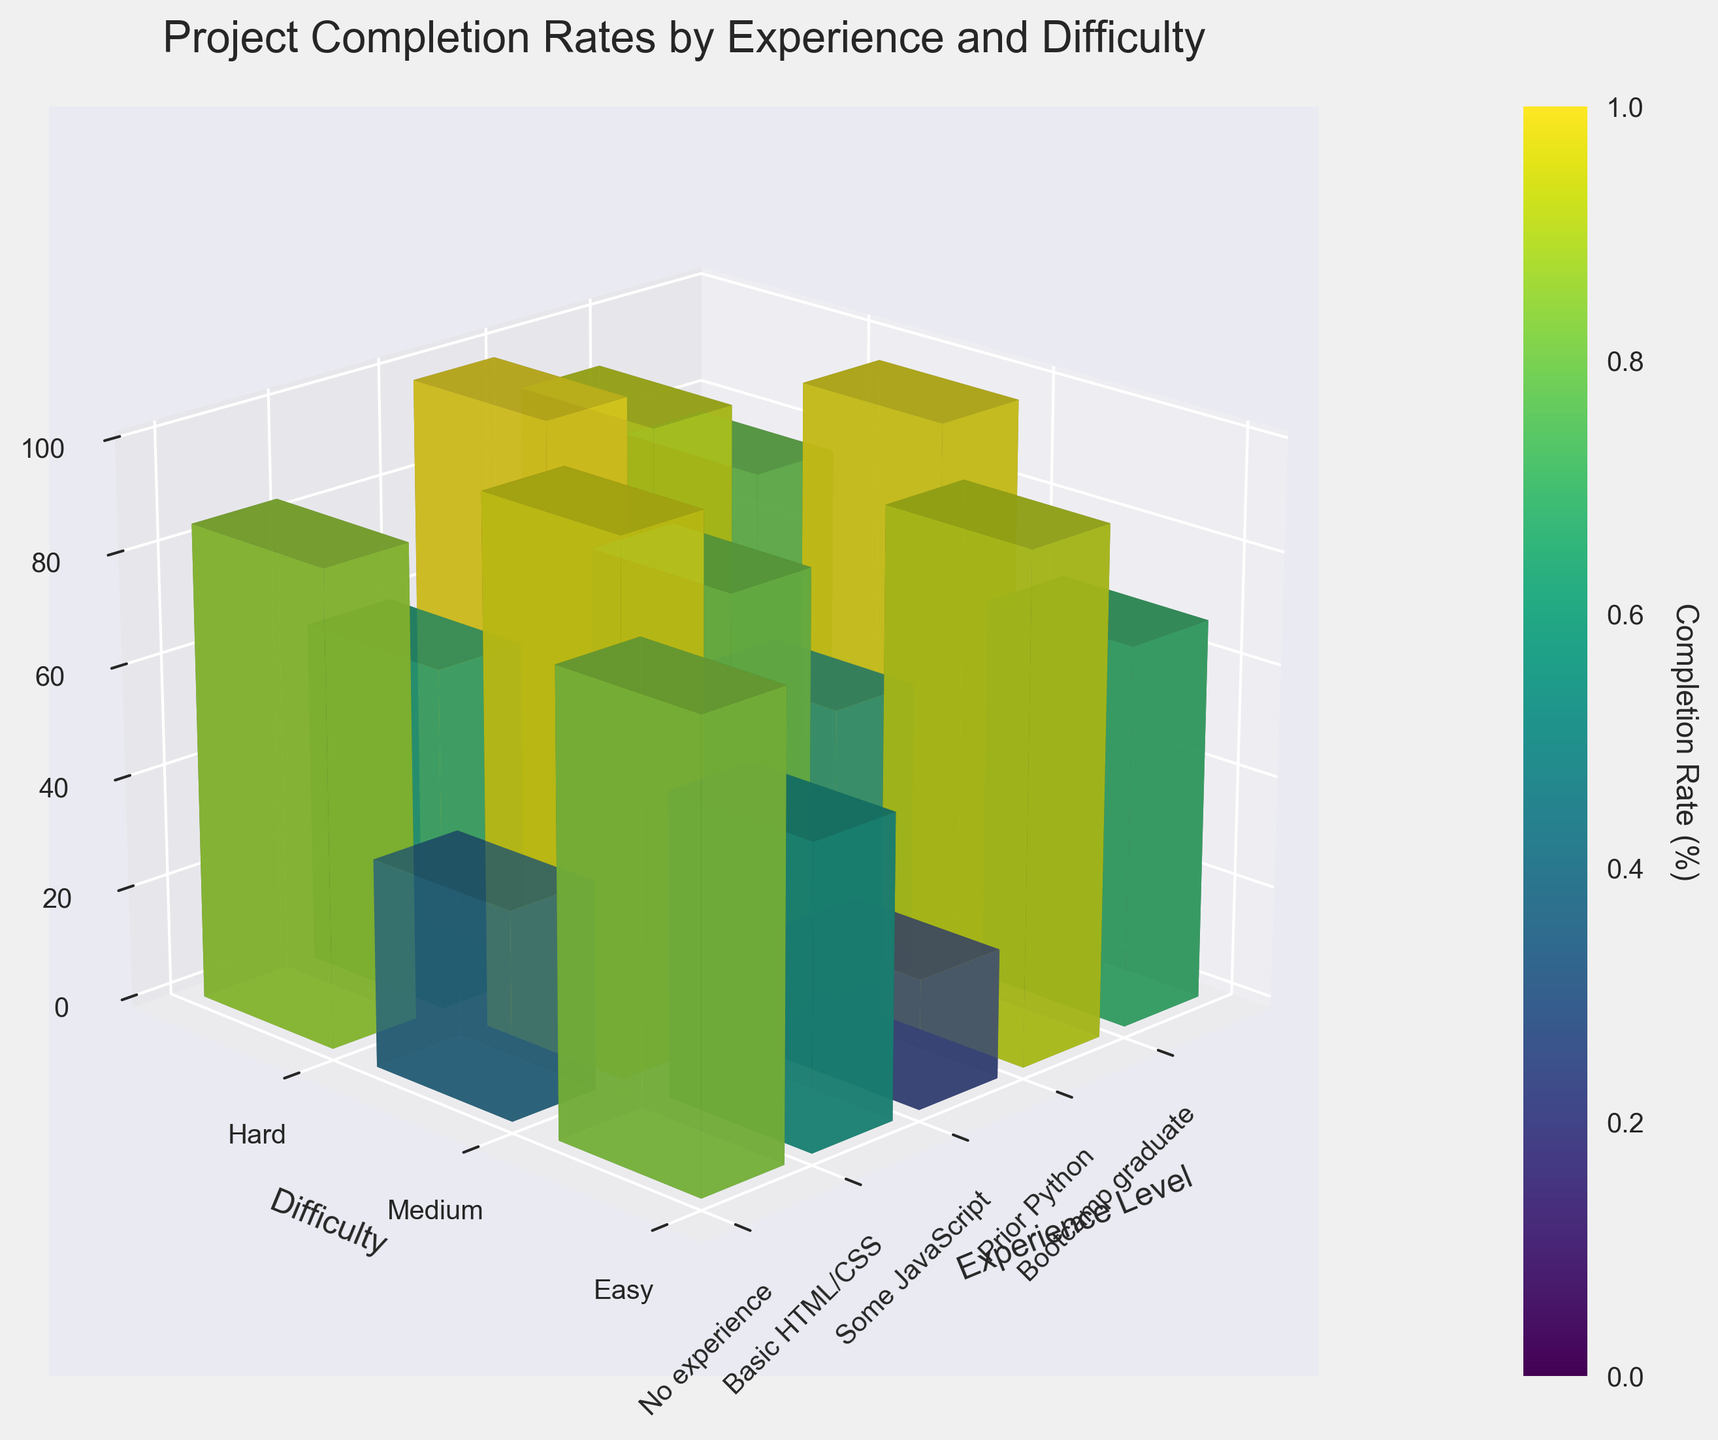What is the title of the 3D bar plot? The title is displayed on top of the figure and reads "Project Completion Rates by Experience and Difficulty". You can access the title by looking at the upper center of the figure.
Answer: Project Completion Rates by Experience and Difficulty What does the Z-axis represent? The Z-axis label is on the right-hand side of the 3D plot and indicates "Completion Rate (%)".
Answer: Completion Rate (%) Which experience level has the highest completion rate for hard projects? To find this, look at the highest bar in the "Hard" category of the Y-axis. The "Bootcamp graduate" category has the highest bar within the "Hard" project difficulty.
Answer: Bootcamp graduate How does the completion rate for medium projects compare between learners with prior Python experience and no experience? To compare, locate the bars under the “Medium” difficulty category (Y-axis). The bar for "Prior Python" (85%) is higher than the bar for "No experience" (54%).
Answer: Prior Python (85%) > No experience (54%) What is the overall trend in completion rates as we move from easy to hard projects across all experience levels? Observing each experience level, generally, the bars decrease in height going from “Easy” (higher bars) to “Hard” (shorter bars), indicating lower completion rates for harder projects.
Answer: Decreasing trend Which group shows the largest drop in completion rate from easy to hard projects? Calculate the difference in heights (completion rates) for each experience level from easy to hard:
No experience: 82 - 23 = 59
Basic HTML/CSS: 91 - 37 = 54
Some JavaScript: 95 - 52 = 43
Prior Python: 97 - 61 = 36
Bootcamp graduate: 99 - 78 = 21
The "No experience" group shows the largest drop of 59.
Answer: No experience (59) For which difficulty category is the completion rate most uniform across different experience levels? Uniformity can be judged by the similarity in height of bars within a difficulty category:
Easy: ranges from 82 to 99
Medium: ranges from 54 to 92
Hard: ranges from 23 to 78
The completion rates for the "Easy" category are most similar across different experience levels.
Answer: Easy Which experience level has the most consistent completion rates across all project difficulties? To find consistency, compare individual height differences for each experience level.
No experience: 59 (82-23), 28 (82-54), 31 (54-23)
Basic HTML/CSS: 54 (91-37), 23 (91-68), 31 (68-37)
Some JavaScript: 43 (95-52), 16 (95-79), 27 (79-52)
Prior Python: 36 (97-61), 12 (97-85), 24 (85-61)
Bootcamp graduate: 21 (99-78), 7 (99-92), 14 (92-78)
Calculate the ranges and variance:
Bootcamp graduate shows the smallest ranges and variance, making it the most consistent.
Answer: Bootcamp graduate What is the average completion rate for "Some JavaScript" experience level across all difficulty categories? To find the average, sum the completion rates for "Some JavaScript" (95, 79, 52) and divide by 3. 
 (95 + 79 + 52) / 3 = 226 / 3 = 75.33
Answer: 75.33% What is the color scheme of the bars and what might it represent? The color scheme appears to be gradient from light to dark in green-yellow hues, typically indicating different values with the lightest color for lower completion rates and the darkest for higher completion rates. This is commonly used to visually differentiate the data values within the same plot.
Answer: Gradient from green to yellow 